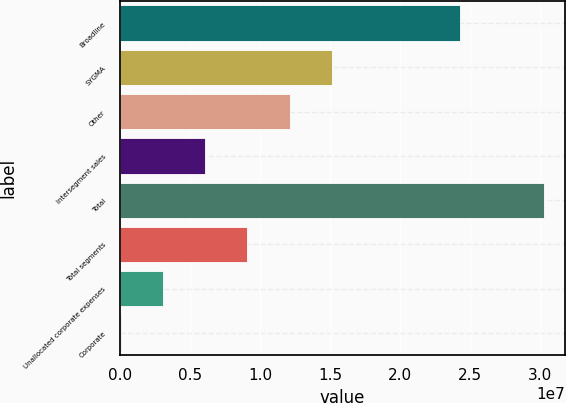Convert chart. <chart><loc_0><loc_0><loc_500><loc_500><bar_chart><fcel>Broadline<fcel>SYGMA<fcel>Other<fcel>Intersegment sales<fcel>Total<fcel>Total segments<fcel>Unallocated corporate expenses<fcel>Corporate<nl><fcel>2.4267e+07<fcel>1.51597e+07<fcel>1.21353e+07<fcel>6.08642e+06<fcel>3.02819e+07<fcel>9.11085e+06<fcel>3.06198e+06<fcel>37543<nl></chart> 